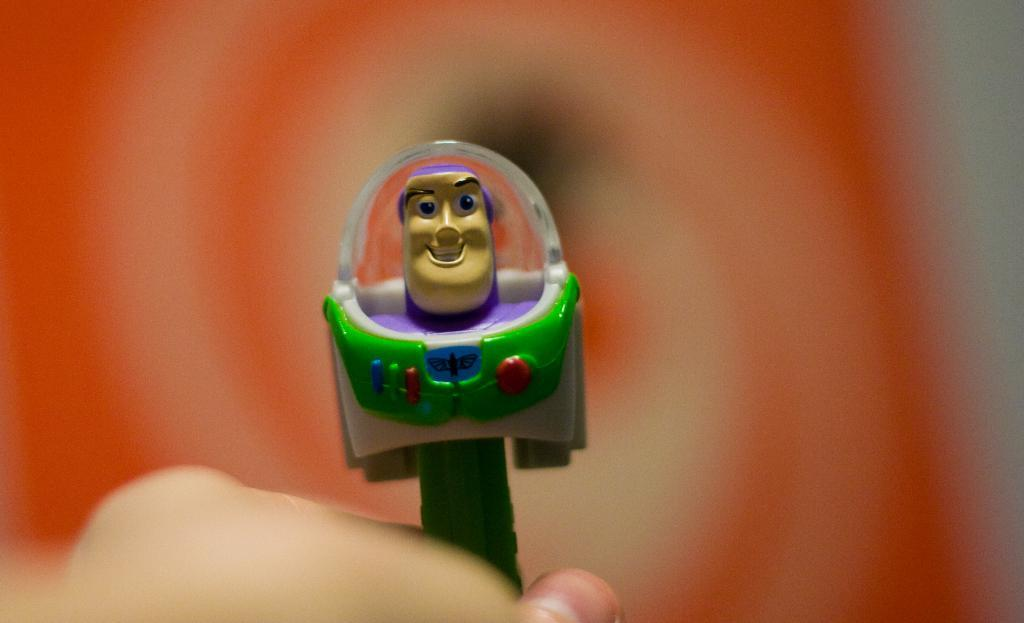What is being held by the person's hand in the image? There is a green toy being held by a person's hand at the bottom of the picture. What colors are used in the background of the image? The background of the image is in red and white colors. How would you describe the quality of the image in the background? The image is blurred in the background. What time of day is depicted in the image? The image does not provide any information about the time of day, so it cannot be determined from the picture. 